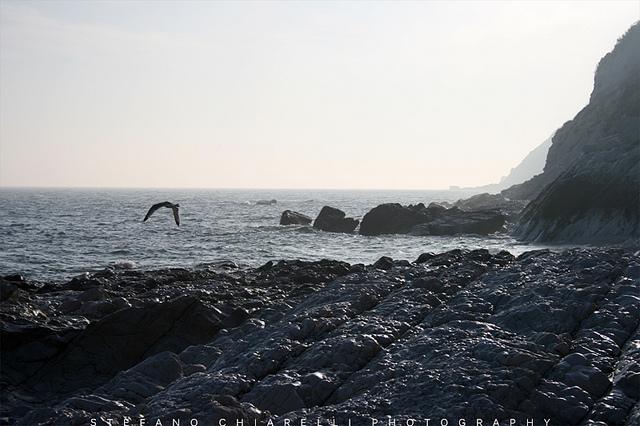Is there an animal in this picture?
Quick response, please. Yes. Can these birds live on these rocks?
Be succinct. Yes. Is the sea rough?
Answer briefly. No. Is this a sandy beach?
Write a very short answer. No. Are these waves high?
Short answer required. No. What is in the background?
Answer briefly. Water. 